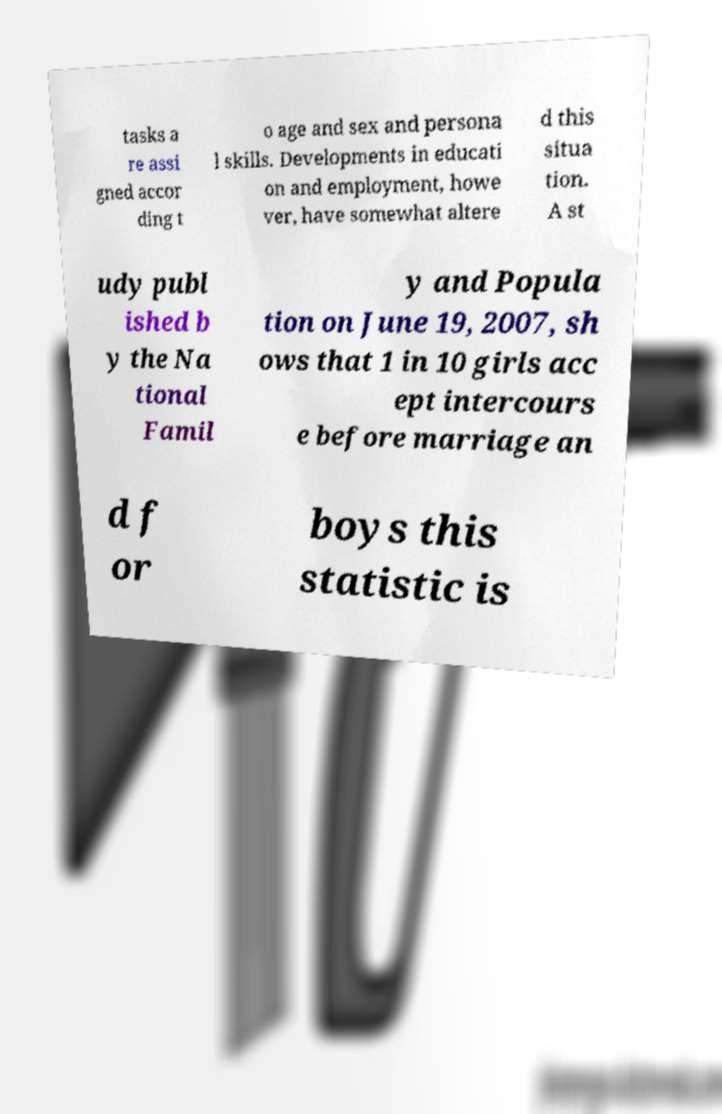Could you assist in decoding the text presented in this image and type it out clearly? tasks a re assi gned accor ding t o age and sex and persona l skills. Developments in educati on and employment, howe ver, have somewhat altere d this situa tion. A st udy publ ished b y the Na tional Famil y and Popula tion on June 19, 2007, sh ows that 1 in 10 girls acc ept intercours e before marriage an d f or boys this statistic is 